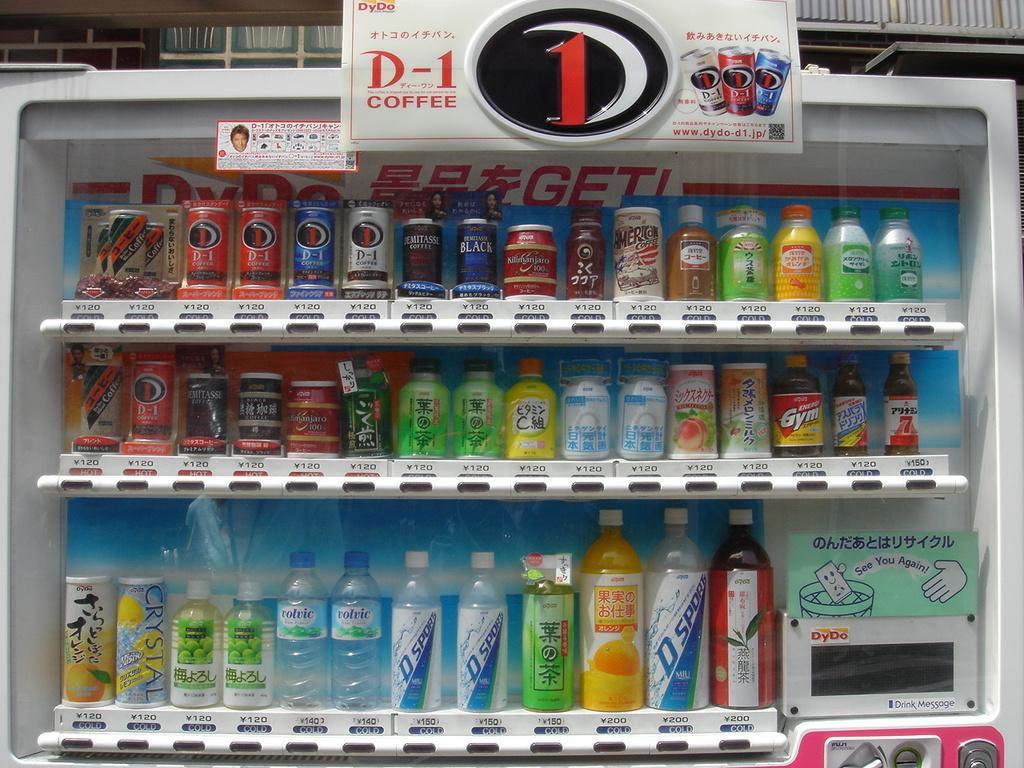<image>
Create a compact narrative representing the image presented. A soda cooler has drinks in it and says D-1 Coffee. 